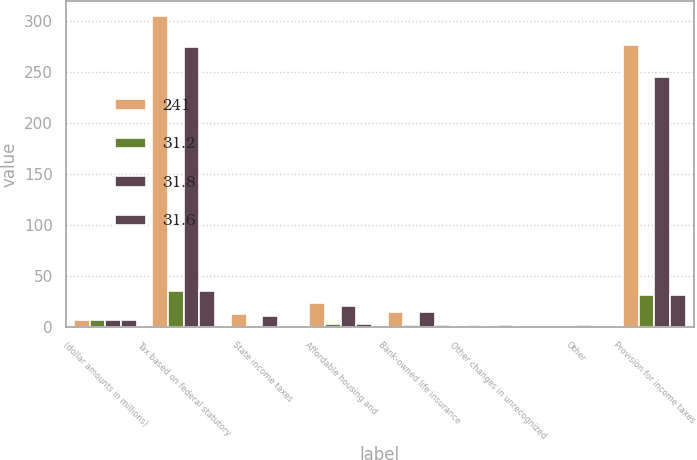Convert chart to OTSL. <chart><loc_0><loc_0><loc_500><loc_500><stacked_bar_chart><ecel><fcel>(dollar amounts in millions)<fcel>Tax based on federal statutory<fcel>State income taxes<fcel>Affordable housing and<fcel>Bank-owned life insurance<fcel>Other changes in unrecognized<fcel>Other<fcel>Provision for income taxes<nl><fcel>241<fcel>6.9<fcel>305<fcel>13<fcel>24<fcel>15<fcel>2<fcel>1<fcel>277<nl><fcel>31.2<fcel>6.9<fcel>35<fcel>1.5<fcel>2.8<fcel>1.7<fcel>0.2<fcel>0.1<fcel>31.8<nl><fcel>31.8<fcel>6.9<fcel>275<fcel>11<fcel>21<fcel>15<fcel>2<fcel>2<fcel>245<nl><fcel>31.6<fcel>6.9<fcel>35<fcel>1.4<fcel>2.6<fcel>1.9<fcel>0.2<fcel>0.4<fcel>31.2<nl></chart> 